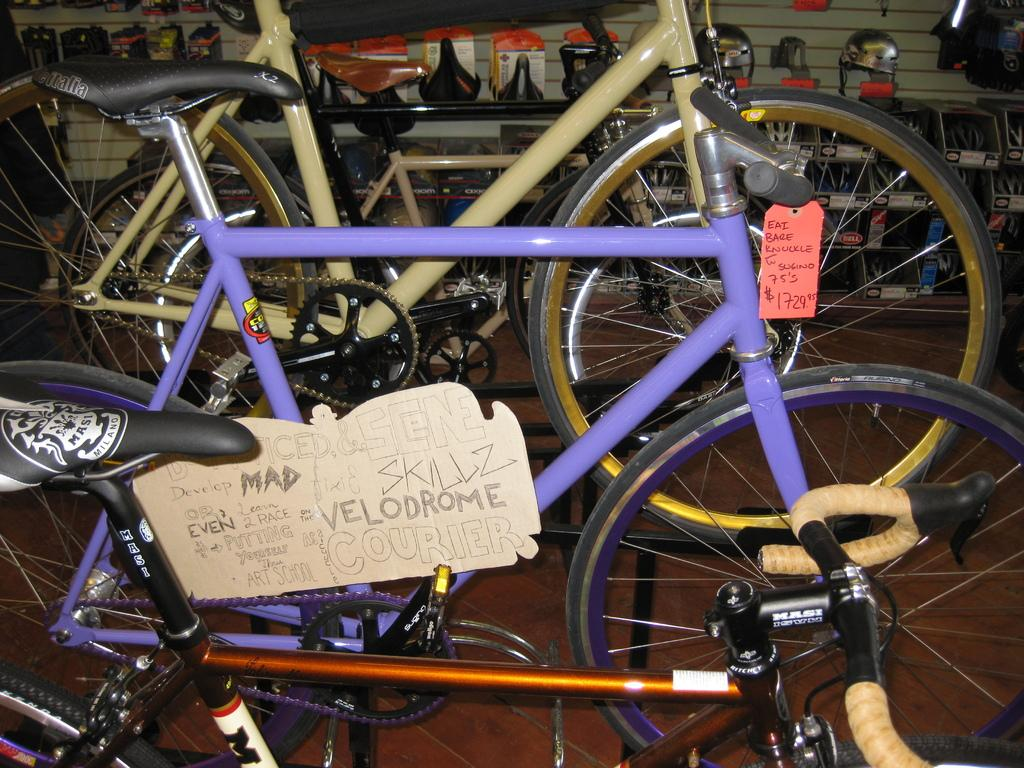What objects are on the floor in the image? There are bicycles on the floor in the image. What can be seen on the bicycles? The bicycles have tags. What safety equipment is visible in the image? There are helmets visible in the background of the image. What is in the background of the image? There is a wall in the background of the image. What type of oil can be seen dripping from the bicycles in the image? There is no oil dripping from the bicycles in the image. Can you tell me how many basketballs are visible in the image? There are no basketballs present in the image. 